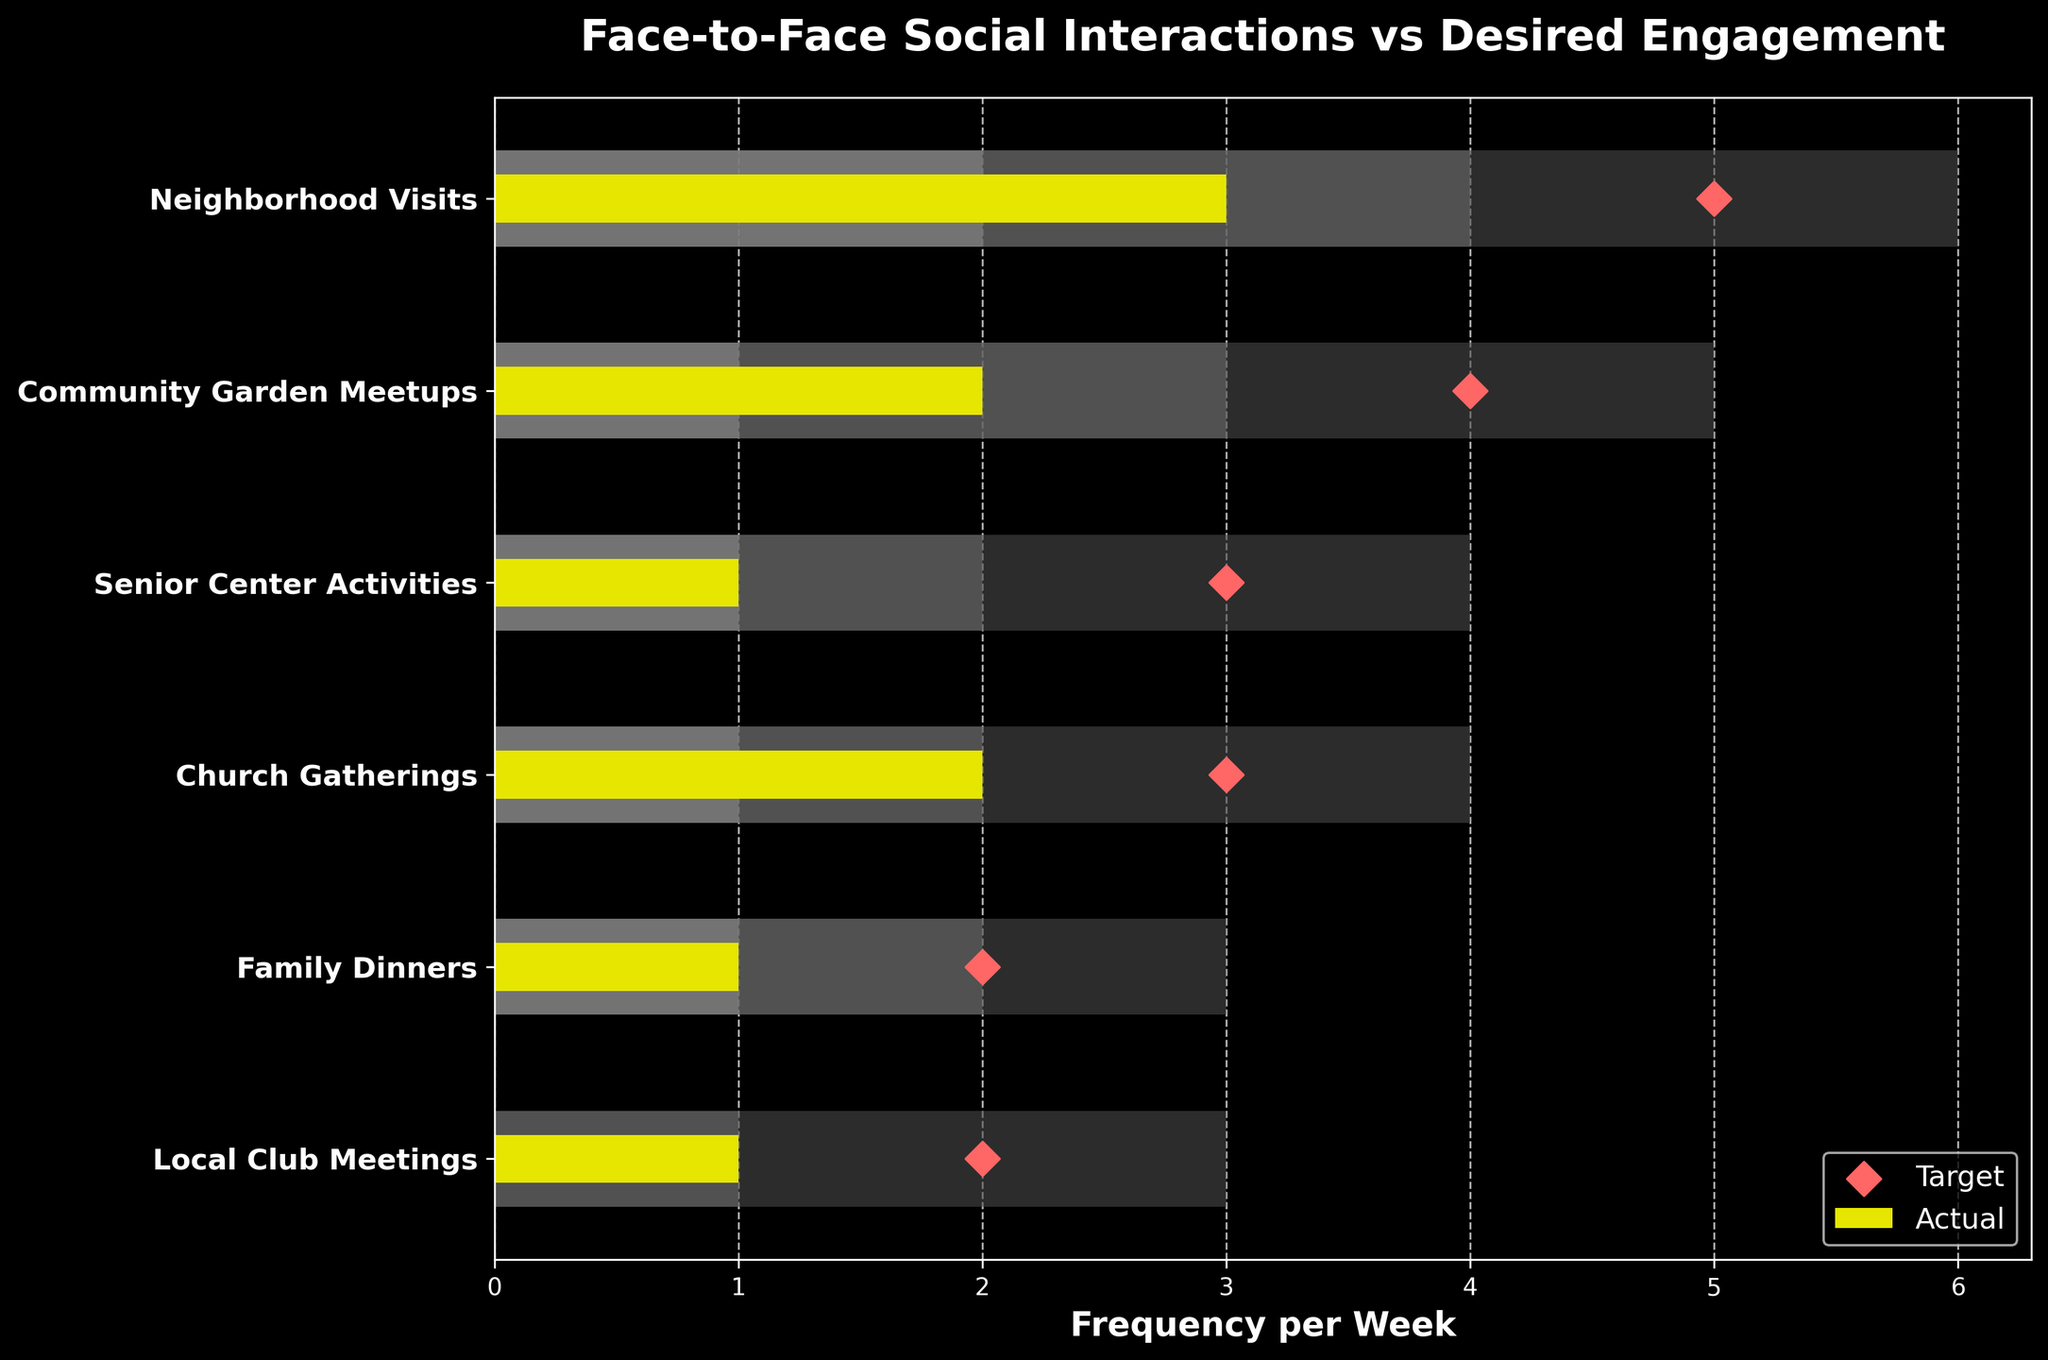What's the title of the chart? The title of the chart is located at the top center and is written in bold font.
Answer: Face-to-Face Social Interactions vs Desired Engagement How many categories are shown in the chart? Count the number of different social interaction types listed on the y-axis.
Answer: Six Which category has the largest actual social interaction value? Compare the yellow bars that represent the actual values for each category. The largest yellow bar corresponds to Neighborhood Visits.
Answer: Neighborhood Visits What is the target value for Community Garden Meetups? Find the diamond marker (target) next to the Community Garden Meetups category on the y-axis.
Answer: 4 For Family Dinners, what is the difference between the actual value and the target value? Subtract the actual value (length of the yellow bar) from the target value (position of the diamond marker) for Family Dinners. The actual value is 1 and the target is 2, so 2 - 1 = 1.
Answer: 1 Which category shows the least desired range (Range3)? Compare the lengths of the darkest bars (representing Range3) and identify the category with the shortest length. This is Local Club Meetings with a range of 3.
Answer: Local Club Meetings Are there any categories where the actual value is equal to the lower value of Range1? Check if the actual yellow bar matches the start of the gray bar (Range1). For Senior Center Activities, both the actual value and lower value of Range1 are 1.
Answer: Yes, Senior Center Activities Which category has the smallest gap between the actual value and the target value? Calculate the differences between the yellow bar lengths and the diamond marker positions for each category. Church Gatherings have an actual value of 2 and a target of 3, resulting in the smallest gap of 1.
Answer: Church Gatherings What is the median target value among all categories? List and sort the target values: [2, 2, 3, 3, 4, 5]. The median is the middle value in ordered data. With even numbers, average the two middle values: (3+3)/2 = 3.
Answer: 3 